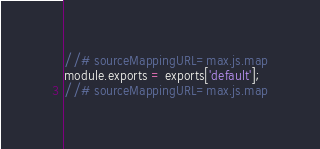Convert code to text. <code><loc_0><loc_0><loc_500><loc_500><_JavaScript_>
//# sourceMappingURL=max.js.map
module.exports = exports['default'];
//# sourceMappingURL=max.js.map</code> 